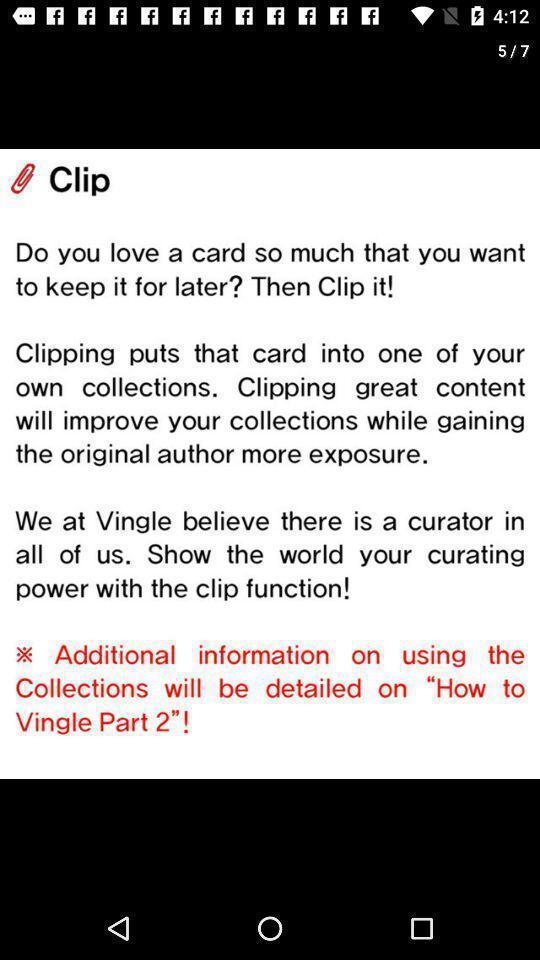Summarize the information in this screenshot. Screen displaying information about a clipping function. 